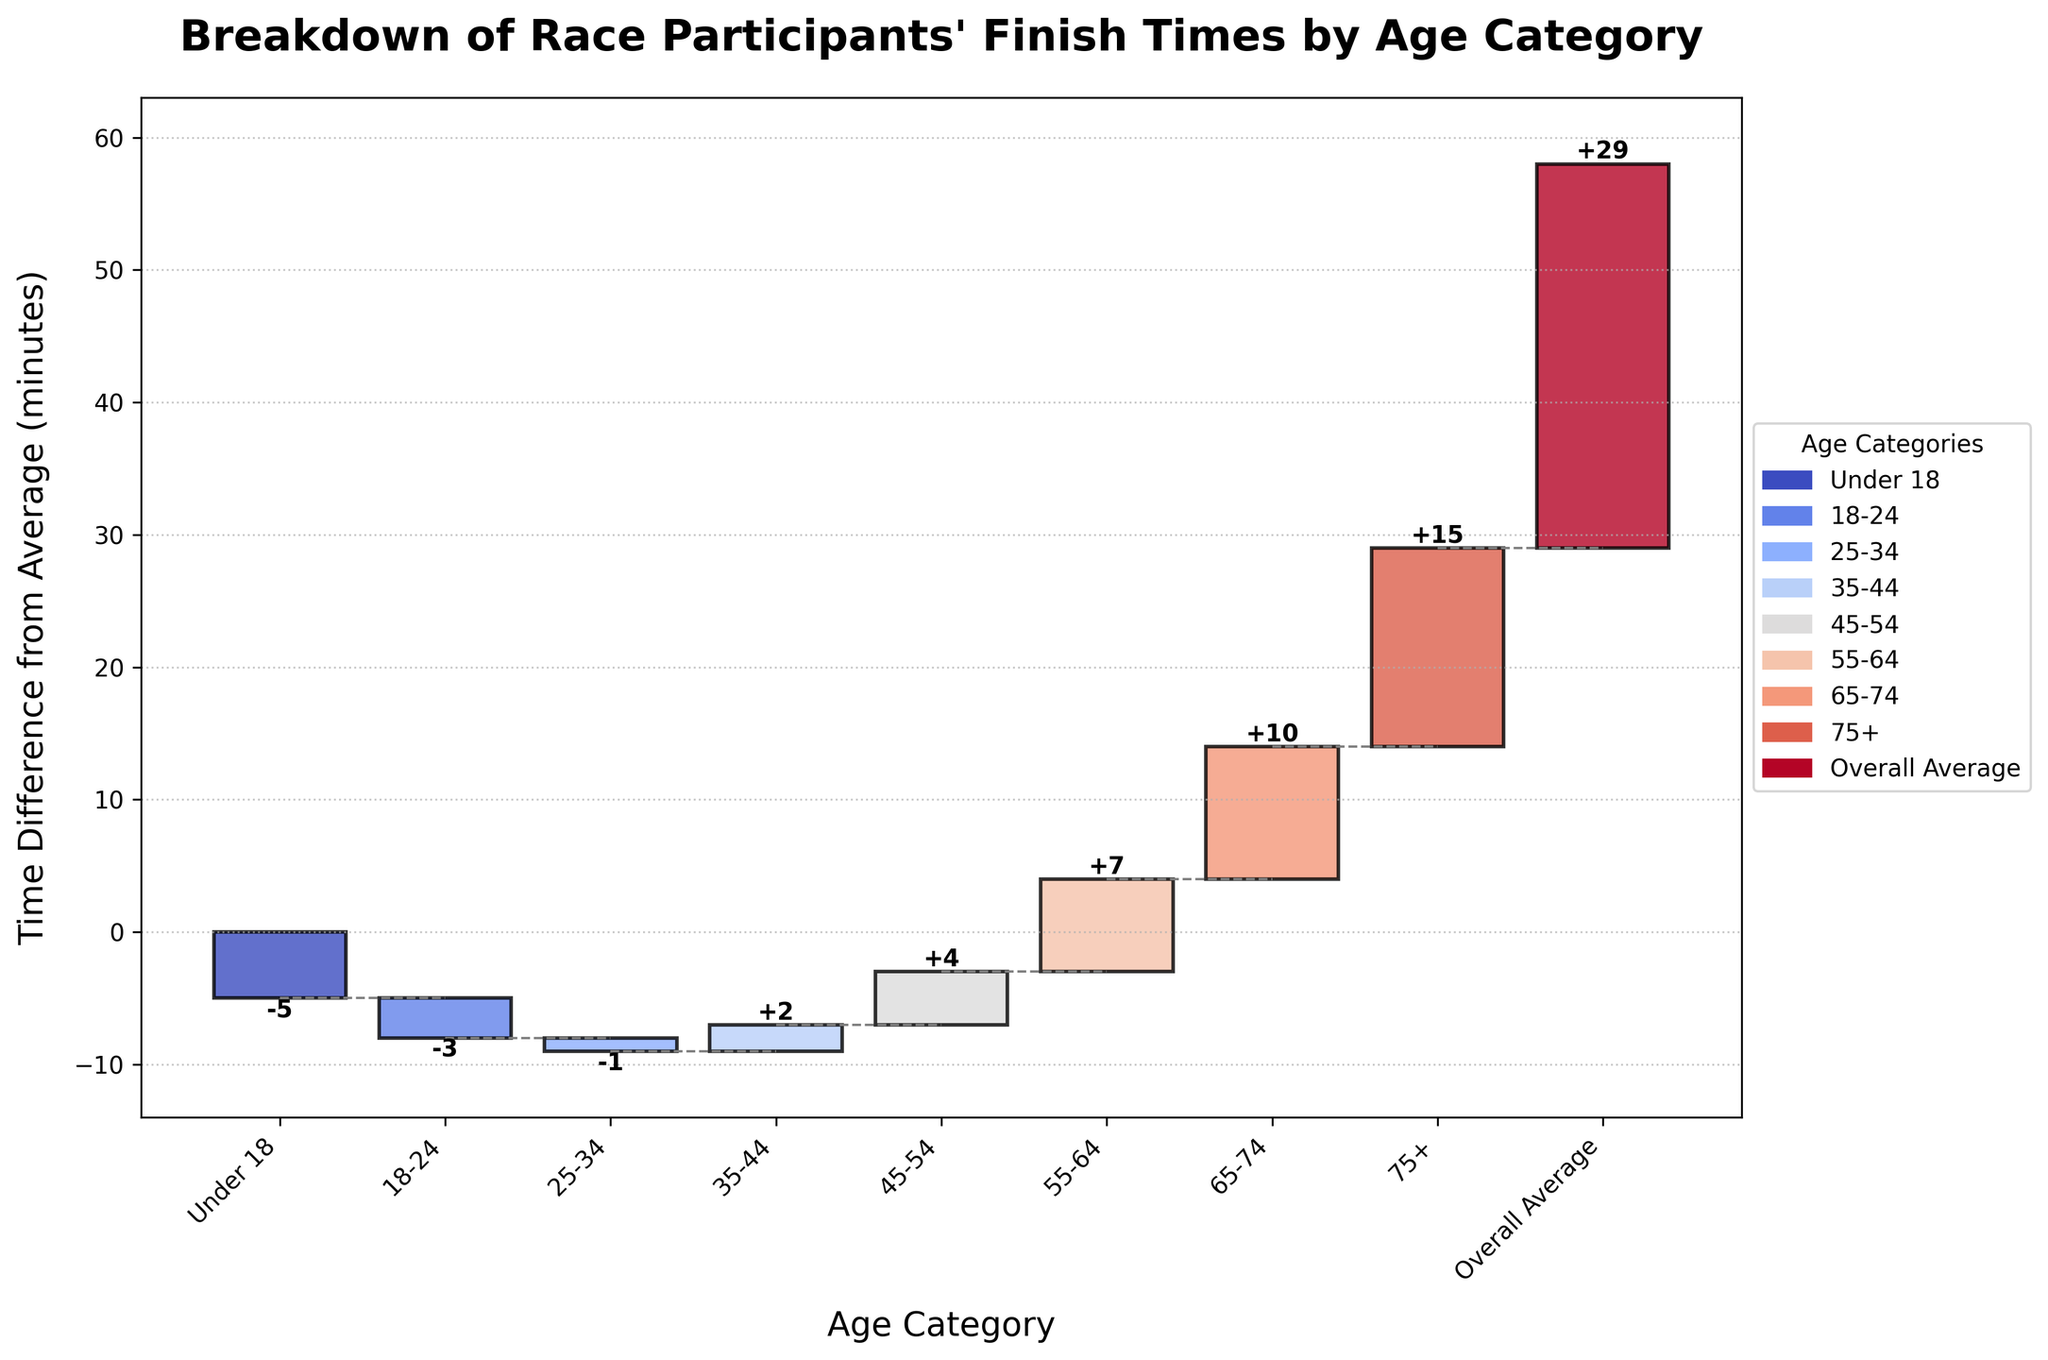What's the title of the chart? The title is displayed at the top of the chart. It reads "Breakdown of Race Participants' Finish Times by Age Category".
Answer: Breakdown of Race Participants' Finish Times by Age Category What is the under 18 age category's finish time difference from the average? The chart shows a bar for the under 18 category with a label indicating the time difference is -5 minutes.
Answer: -5 minutes Which age category has the highest positive difference from the overall average? By examining the heights of the bars, the 75+ age category has the highest positive difference at 15 minutes.
Answer: 75+ What is the range of time differences displayed on this chart? The cumulative time difference ranges from -5 to 29 minutes. The smallest difference shown is for "Under 18" at -5 minutes and the highest is the "Overall Average" at 29 minutes. Therefore, the range is 34 minutes.
Answer: 34 minutes How does the 35-44 age category compare to the overall average finish time? The finish time for the 35-44 age category is 2 minutes above the overall average.
Answer: 2 minutes above What is the cumulative time difference for the 65-74 age category? The cumulative sum up to the 65-74 age category is 14 minutes (calculating step-by-step: -5 + -3 + -1 + 2 + 4 + 7 + 10).
Answer: 14 minutes Which age category has the smallest negative difference from the overall average? Among the negative differences, the 25-34 category has the smallest negative value shown as -1 minute.
Answer: 25-34 What is the sum of the time differences from the 25-34 and 45-54 age categories? The time differences for 25-34 and 45-54 are -1 and 4 minutes respectively. Adding them: -1 + 4 = 3 minutes.
Answer: 3 minutes How many age categories have a positive time difference from the average? By examining the bars, the positive time differences are for age categories 35-44, 45-54, 55-64, 65-74, and 75+. In total, there are 5 categories.
Answer: 5 Which age category has a time difference closest to zero? The category 25-34 has a time difference of -1 minute which is closest to zero compared to the other categories.
Answer: 25-34 